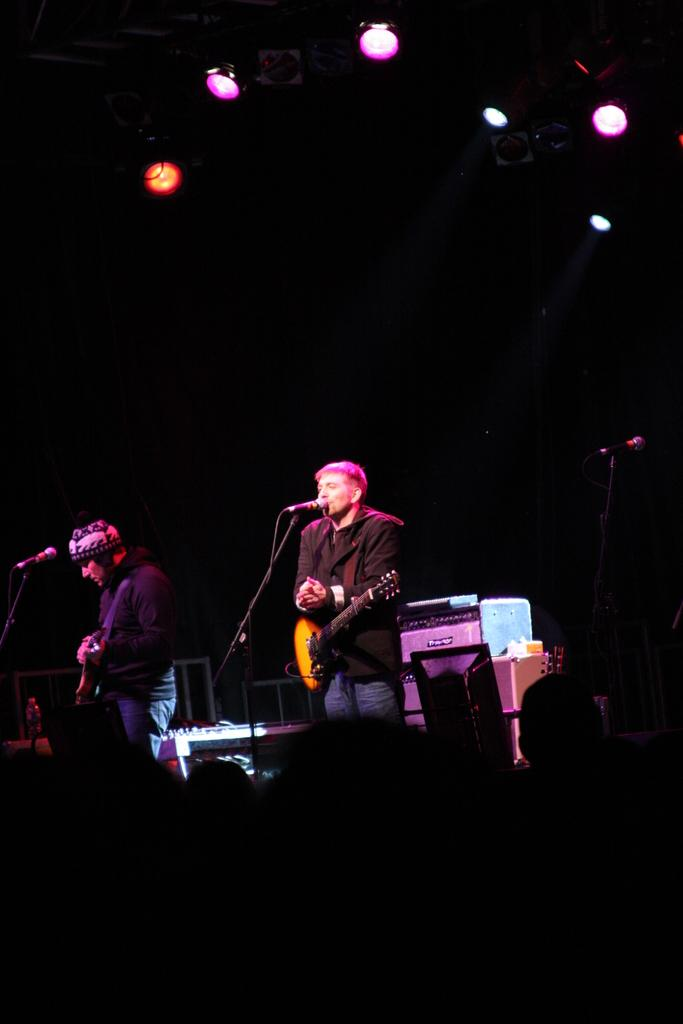How many people are in the image? There are two people in the image. Where are the two people located? The two people are standing on a stage. What are the two people holding? One person is holding a guitar, and the other person is also holding a guitar. What is in front of the two people? There is a microphone (mic) in front of the two people. What year is depicted in the image? The image does not depict a specific year; it is a photograph of two people on a stage with guitars and a microphone. How many toes can be seen in the image? There are no visible toes in the image; it focuses on the two people, their guitars, and the microphone. 